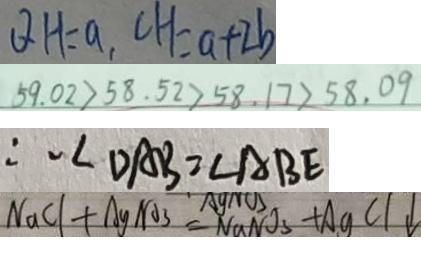Convert formula to latex. <formula><loc_0><loc_0><loc_500><loc_500>Q H = a , C H = a + 2 b 
 5 9 . 0 2 > 5 8 . 5 2 > 5 8 . 1 7 > 5 8 . 0 9 
 \therefore \angle D A B = \angle A B E 
 N a C l + A g N O _ { 3 } = N a N O _ { 3 } + A g C l \downarrow</formula> 